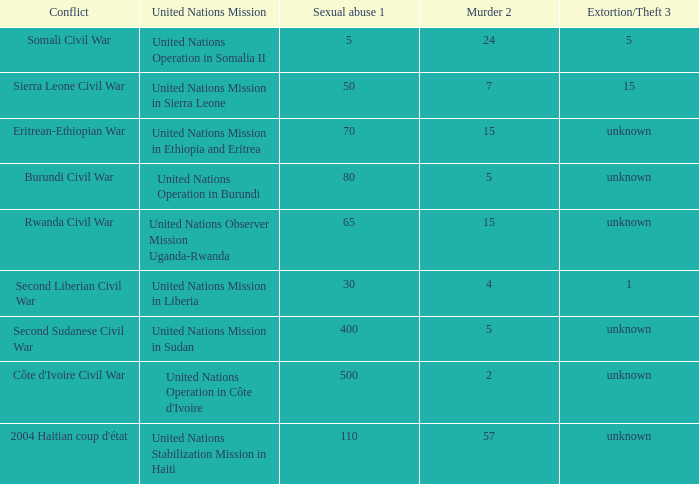What is the sexual abuse rate where the conflict is the Second Sudanese Civil War? 400.0. 